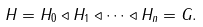Convert formula to latex. <formula><loc_0><loc_0><loc_500><loc_500>H = H _ { 0 } \triangleleft H _ { 1 } \triangleleft \cdots \triangleleft H _ { n } = G .</formula> 